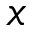<formula> <loc_0><loc_0><loc_500><loc_500>x</formula> 